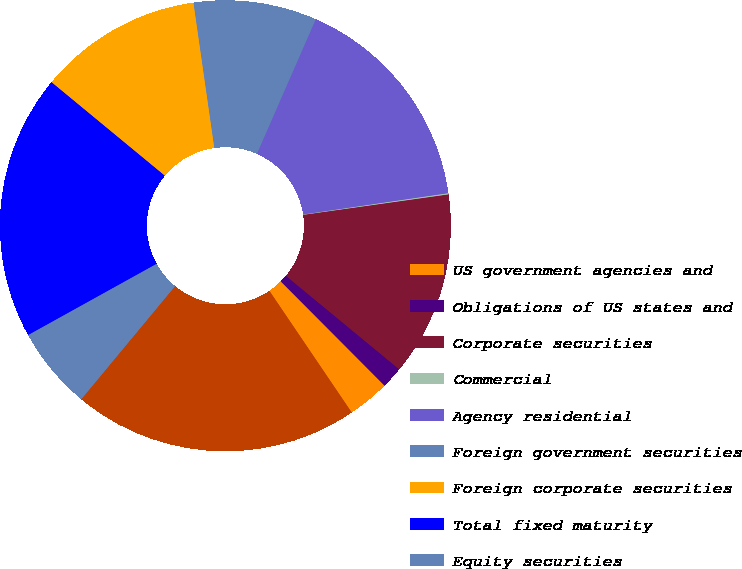Convert chart. <chart><loc_0><loc_0><loc_500><loc_500><pie_chart><fcel>US government agencies and<fcel>Obligations of US states and<fcel>Corporate securities<fcel>Commercial<fcel>Agency residential<fcel>Foreign government securities<fcel>Foreign corporate securities<fcel>Total fixed maturity<fcel>Equity securities<fcel>Total<nl><fcel>3.0%<fcel>1.55%<fcel>13.21%<fcel>0.09%<fcel>16.12%<fcel>8.83%<fcel>11.75%<fcel>19.04%<fcel>5.92%<fcel>20.49%<nl></chart> 